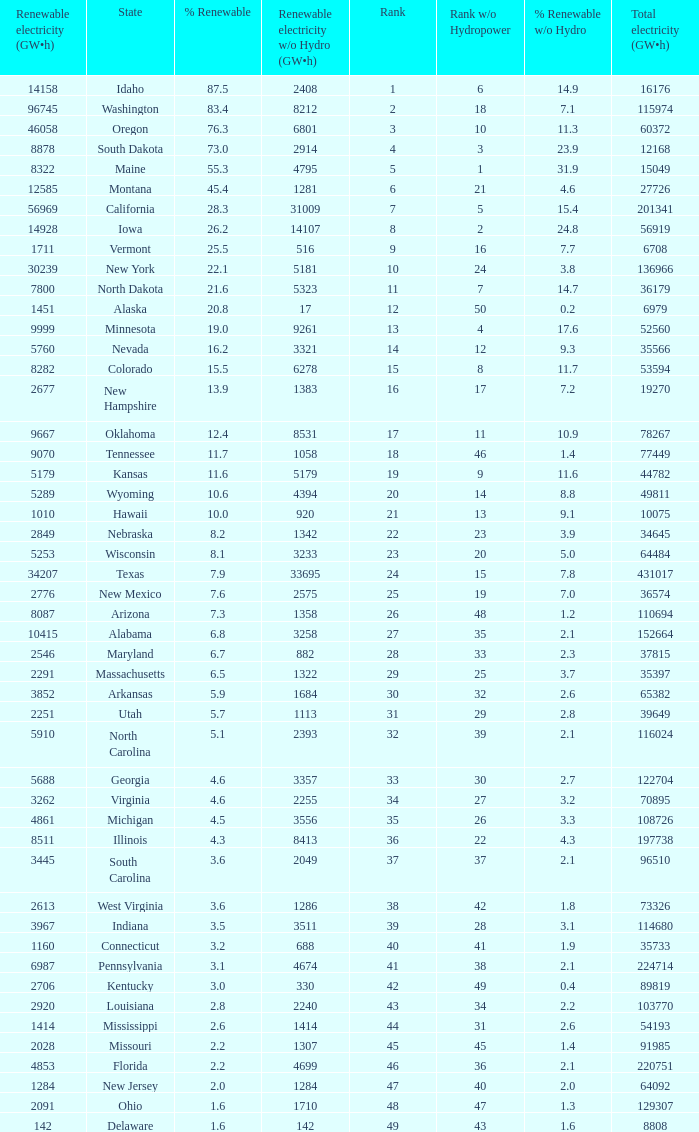What is the percentage of renewable electricity without hydrogen power in the state of South Dakota? 23.9. 